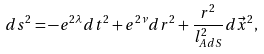<formula> <loc_0><loc_0><loc_500><loc_500>d s ^ { 2 } = - e ^ { 2 \lambda } d t ^ { 2 } + e ^ { 2 \nu } d r ^ { 2 } + \frac { r ^ { 2 } } { l _ { A d S } ^ { 2 } } d \vec { x } ^ { 2 } ,</formula> 